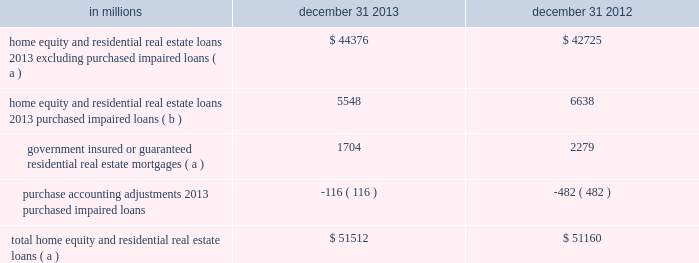Is used to monitor the risk in the loan classes .
Loans with higher fico scores and lower ltvs tend to have a lower level of risk .
Conversely , loans with lower fico scores , higher ltvs , and in certain geographic locations tend to have a higher level of risk .
In the first quarter of 2013 , we refined our process for the home equity and residential real estate asset quality indicators shown in the tables .
These refinements include , but are not limited to , improvements in the process for determining lien position and ltv in both table 67 and table 68 .
Additionally , as of the first quarter of 2013 , we are now presenting table 67 at recorded investment as opposed to our prior presentation of outstanding balance .
Table 68 continues to be presented at outstanding balance .
Both the 2013 and 2012 period end balance disclosures are presented in the below tables using this refined process .
Consumer purchased impaired loan class estimates of the expected cash flows primarily determine the credit impacts of consumer purchased impaired loans .
Consumer cash flow estimates are influenced by a number of credit related items , which include , but are not limited to : estimated real estate values , payment patterns , updated fico scores , the current economic environment , updated ltv ratios and the date of origination .
These key factors are monitored to help ensure that concentrations of risk are mitigated and cash flows are maximized .
See note 6 purchased loans for additional information .
Table 66 : home equity and residential real estate balances in millions december 31 december 31 home equity and residential real estate loans 2013 excluding purchased impaired loans ( a ) $ 44376 $ 42725 home equity and residential real estate loans 2013 purchased impaired loans ( b ) 5548 6638 government insured or guaranteed residential real estate mortgages ( a ) 1704 2279 purchase accounting adjustments 2013 purchased impaired loans ( 116 ) ( 482 ) total home equity and residential real estate loans ( a ) $ 51512 $ 51160 ( a ) represents recorded investment .
( b ) represents outstanding balance .
136 the pnc financial services group , inc .
2013 form 10-k .
Is used to monitor the risk in the loan classes .
Loans with higher fico scores and lower ltvs tend to have a lower level of risk .
Conversely , loans with lower fico scores , higher ltvs , and in certain geographic locations tend to have a higher level of risk .
In the first quarter of 2013 , we refined our process for the home equity and residential real estate asset quality indicators shown in the following tables .
These refinements include , but are not limited to , improvements in the process for determining lien position and ltv in both table 67 and table 68 .
Additionally , as of the first quarter of 2013 , we are now presenting table 67 at recorded investment as opposed to our prior presentation of outstanding balance .
Table 68 continues to be presented at outstanding balance .
Both the 2013 and 2012 period end balance disclosures are presented in the below tables using this refined process .
Consumer purchased impaired loan class estimates of the expected cash flows primarily determine the credit impacts of consumer purchased impaired loans .
Consumer cash flow estimates are influenced by a number of credit related items , which include , but are not limited to : estimated real estate values , payment patterns , updated fico scores , the current economic environment , updated ltv ratios and the date of origination .
These key factors are monitored to help ensure that concentrations of risk are mitigated and cash flows are maximized .
See note 6 purchased loans for additional information .
Table 66 : home equity and residential real estate balances in millions december 31 december 31 home equity and residential real estate loans 2013 excluding purchased impaired loans ( a ) $ 44376 $ 42725 home equity and residential real estate loans 2013 purchased impaired loans ( b ) 5548 6638 government insured or guaranteed residential real estate mortgages ( a ) 1704 2279 purchase accounting adjustments 2013 purchased impaired loans ( 116 ) ( 482 ) total home equity and residential real estate loans ( a ) $ 51512 $ 51160 ( a ) represents recorded investment .
( b ) represents outstanding balance .
136 the pnc financial services group , inc .
2013 form 10-k .
For 2012 and 2013 what was average total home equity and residential real estate loans in millions? 
Computations: ((51512 + 51160) / 2)
Answer: 51336.0. 